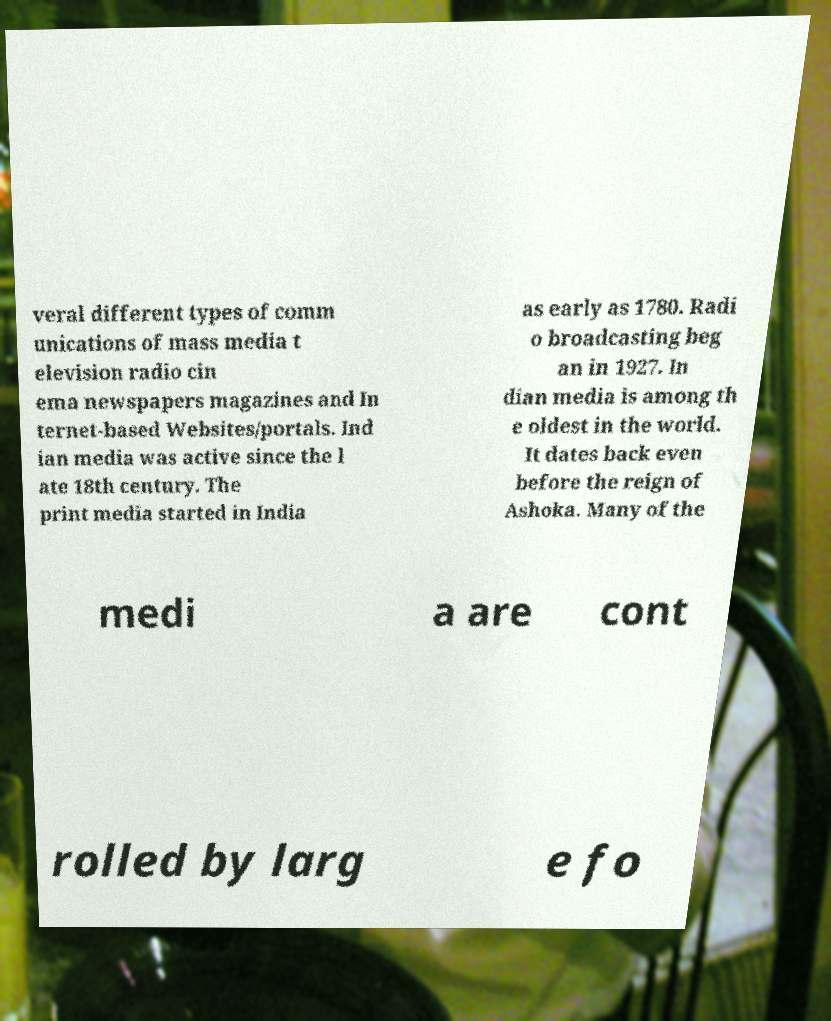There's text embedded in this image that I need extracted. Can you transcribe it verbatim? veral different types of comm unications of mass media t elevision radio cin ema newspapers magazines and In ternet-based Websites/portals. Ind ian media was active since the l ate 18th century. The print media started in India as early as 1780. Radi o broadcasting beg an in 1927. In dian media is among th e oldest in the world. It dates back even before the reign of Ashoka. Many of the medi a are cont rolled by larg e fo 